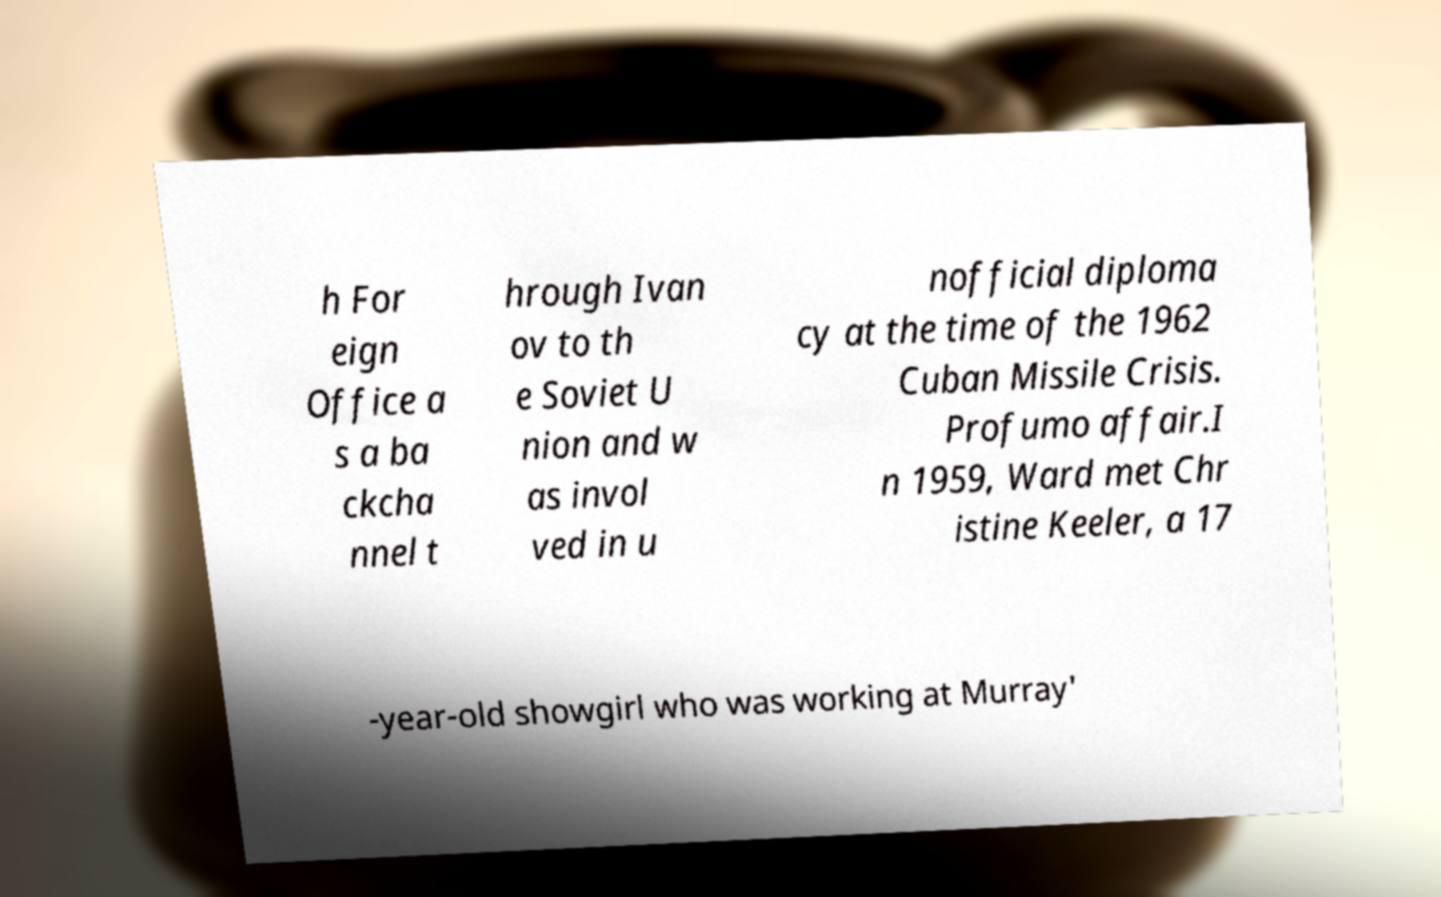For documentation purposes, I need the text within this image transcribed. Could you provide that? h For eign Office a s a ba ckcha nnel t hrough Ivan ov to th e Soviet U nion and w as invol ved in u nofficial diploma cy at the time of the 1962 Cuban Missile Crisis. Profumo affair.I n 1959, Ward met Chr istine Keeler, a 17 -year-old showgirl who was working at Murray' 